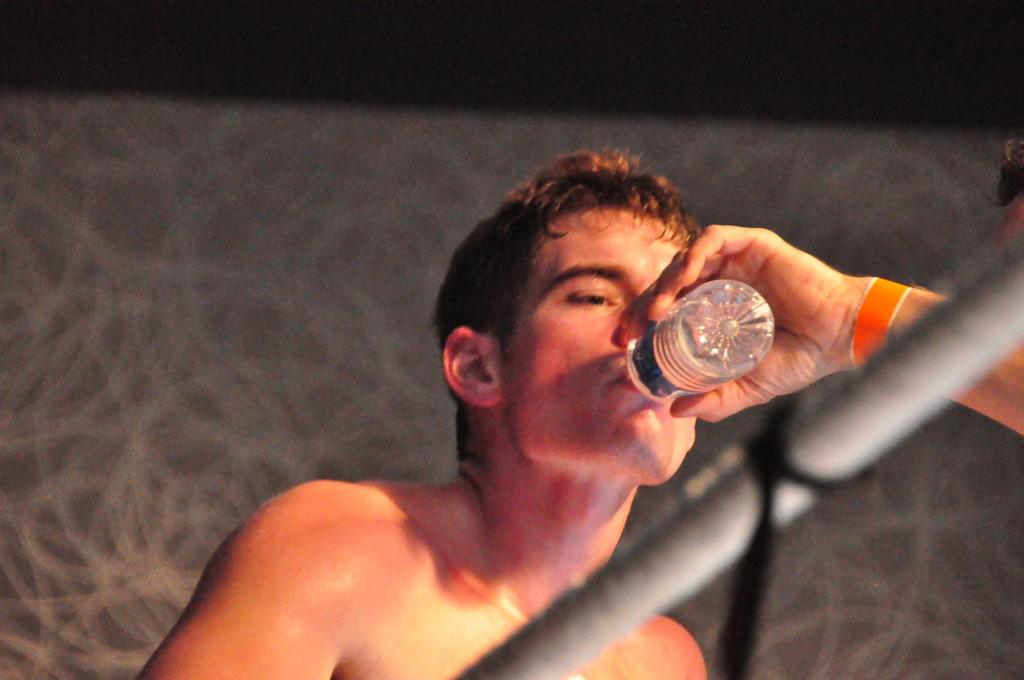What is the person in the image doing with the bottle? The person is drinking water from the bottle. Who else is involved with the bottle in the image? Another person is holding the bottle. Can you describe the appearance of the person holding the bottle? The person holding the bottle is wearing an orange wristband. What can be seen on the right side of the image? There is a rod on the right side of the image. How would you describe the background of the image? The background of the image is blurred. What type of experience is the giraffe having in the image? There is no giraffe present in the image, so it is not possible to determine any experience it might be having. 